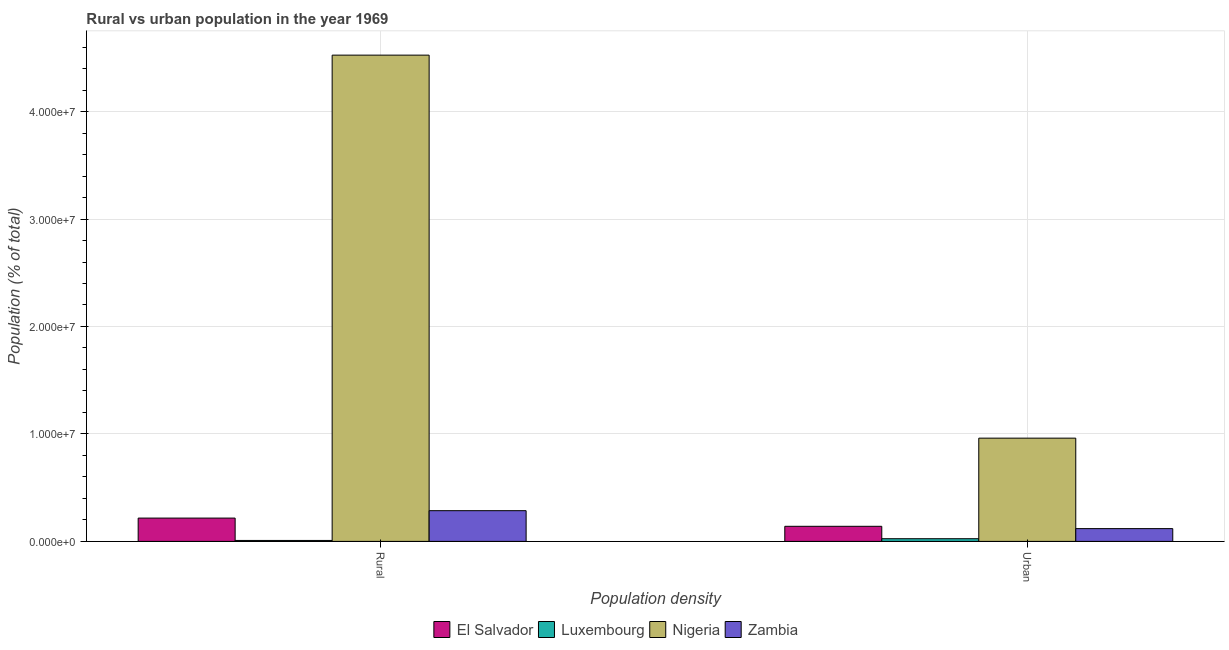How many groups of bars are there?
Your answer should be compact. 2. Are the number of bars on each tick of the X-axis equal?
Offer a very short reply. Yes. How many bars are there on the 2nd tick from the right?
Make the answer very short. 4. What is the label of the 2nd group of bars from the left?
Your answer should be very brief. Urban. What is the urban population density in Luxembourg?
Keep it short and to the point. 2.49e+05. Across all countries, what is the maximum rural population density?
Provide a short and direct response. 4.53e+07. Across all countries, what is the minimum rural population density?
Your response must be concise. 8.81e+04. In which country was the rural population density maximum?
Provide a succinct answer. Nigeria. In which country was the urban population density minimum?
Provide a succinct answer. Luxembourg. What is the total urban population density in the graph?
Make the answer very short. 1.24e+07. What is the difference between the urban population density in Luxembourg and that in Nigeria?
Provide a succinct answer. -9.36e+06. What is the difference between the urban population density in El Salvador and the rural population density in Zambia?
Provide a succinct answer. -1.45e+06. What is the average rural population density per country?
Your answer should be compact. 1.26e+07. What is the difference between the urban population density and rural population density in Zambia?
Your response must be concise. -1.67e+06. What is the ratio of the rural population density in Nigeria to that in El Salvador?
Your response must be concise. 20.87. Is the urban population density in Zambia less than that in Nigeria?
Offer a very short reply. Yes. In how many countries, is the urban population density greater than the average urban population density taken over all countries?
Provide a succinct answer. 1. What does the 2nd bar from the left in Urban represents?
Offer a terse response. Luxembourg. What does the 3rd bar from the right in Urban represents?
Offer a terse response. Luxembourg. How many bars are there?
Give a very brief answer. 8. Are all the bars in the graph horizontal?
Provide a succinct answer. No. Are the values on the major ticks of Y-axis written in scientific E-notation?
Offer a terse response. Yes. Does the graph contain any zero values?
Your response must be concise. No. How are the legend labels stacked?
Your response must be concise. Horizontal. What is the title of the graph?
Your answer should be compact. Rural vs urban population in the year 1969. Does "Guinea" appear as one of the legend labels in the graph?
Give a very brief answer. No. What is the label or title of the X-axis?
Make the answer very short. Population density. What is the label or title of the Y-axis?
Provide a short and direct response. Population (% of total). What is the Population (% of total) of El Salvador in Rural?
Offer a terse response. 2.17e+06. What is the Population (% of total) of Luxembourg in Rural?
Make the answer very short. 8.81e+04. What is the Population (% of total) in Nigeria in Rural?
Offer a terse response. 4.53e+07. What is the Population (% of total) in Zambia in Rural?
Provide a short and direct response. 2.86e+06. What is the Population (% of total) in El Salvador in Urban?
Your response must be concise. 1.40e+06. What is the Population (% of total) of Luxembourg in Urban?
Your answer should be compact. 2.49e+05. What is the Population (% of total) in Nigeria in Urban?
Your response must be concise. 9.61e+06. What is the Population (% of total) of Zambia in Urban?
Offer a terse response. 1.19e+06. Across all Population density, what is the maximum Population (% of total) in El Salvador?
Provide a short and direct response. 2.17e+06. Across all Population density, what is the maximum Population (% of total) of Luxembourg?
Your response must be concise. 2.49e+05. Across all Population density, what is the maximum Population (% of total) in Nigeria?
Make the answer very short. 4.53e+07. Across all Population density, what is the maximum Population (% of total) in Zambia?
Offer a very short reply. 2.86e+06. Across all Population density, what is the minimum Population (% of total) of El Salvador?
Keep it short and to the point. 1.40e+06. Across all Population density, what is the minimum Population (% of total) of Luxembourg?
Your answer should be very brief. 8.81e+04. Across all Population density, what is the minimum Population (% of total) of Nigeria?
Keep it short and to the point. 9.61e+06. Across all Population density, what is the minimum Population (% of total) in Zambia?
Offer a terse response. 1.19e+06. What is the total Population (% of total) in El Salvador in the graph?
Your answer should be very brief. 3.57e+06. What is the total Population (% of total) in Luxembourg in the graph?
Your answer should be compact. 3.38e+05. What is the total Population (% of total) in Nigeria in the graph?
Your answer should be compact. 5.49e+07. What is the total Population (% of total) of Zambia in the graph?
Your response must be concise. 4.05e+06. What is the difference between the Population (% of total) in El Salvador in Rural and that in Urban?
Provide a short and direct response. 7.64e+05. What is the difference between the Population (% of total) of Luxembourg in Rural and that in Urban?
Your answer should be compact. -1.61e+05. What is the difference between the Population (% of total) of Nigeria in Rural and that in Urban?
Your answer should be very brief. 3.56e+07. What is the difference between the Population (% of total) in Zambia in Rural and that in Urban?
Offer a terse response. 1.67e+06. What is the difference between the Population (% of total) of El Salvador in Rural and the Population (% of total) of Luxembourg in Urban?
Offer a terse response. 1.92e+06. What is the difference between the Population (% of total) in El Salvador in Rural and the Population (% of total) in Nigeria in Urban?
Ensure brevity in your answer.  -7.44e+06. What is the difference between the Population (% of total) of El Salvador in Rural and the Population (% of total) of Zambia in Urban?
Offer a terse response. 9.80e+05. What is the difference between the Population (% of total) in Luxembourg in Rural and the Population (% of total) in Nigeria in Urban?
Keep it short and to the point. -9.52e+06. What is the difference between the Population (% of total) in Luxembourg in Rural and the Population (% of total) in Zambia in Urban?
Provide a short and direct response. -1.10e+06. What is the difference between the Population (% of total) of Nigeria in Rural and the Population (% of total) of Zambia in Urban?
Your answer should be compact. 4.41e+07. What is the average Population (% of total) in El Salvador per Population density?
Your response must be concise. 1.79e+06. What is the average Population (% of total) in Luxembourg per Population density?
Keep it short and to the point. 1.69e+05. What is the average Population (% of total) of Nigeria per Population density?
Provide a succinct answer. 2.74e+07. What is the average Population (% of total) of Zambia per Population density?
Ensure brevity in your answer.  2.02e+06. What is the difference between the Population (% of total) in El Salvador and Population (% of total) in Luxembourg in Rural?
Provide a succinct answer. 2.08e+06. What is the difference between the Population (% of total) of El Salvador and Population (% of total) of Nigeria in Rural?
Offer a very short reply. -4.31e+07. What is the difference between the Population (% of total) in El Salvador and Population (% of total) in Zambia in Rural?
Your answer should be compact. -6.90e+05. What is the difference between the Population (% of total) of Luxembourg and Population (% of total) of Nigeria in Rural?
Your answer should be very brief. -4.52e+07. What is the difference between the Population (% of total) of Luxembourg and Population (% of total) of Zambia in Rural?
Offer a very short reply. -2.77e+06. What is the difference between the Population (% of total) in Nigeria and Population (% of total) in Zambia in Rural?
Offer a very short reply. 4.24e+07. What is the difference between the Population (% of total) in El Salvador and Population (% of total) in Luxembourg in Urban?
Your response must be concise. 1.15e+06. What is the difference between the Population (% of total) in El Salvador and Population (% of total) in Nigeria in Urban?
Provide a short and direct response. -8.20e+06. What is the difference between the Population (% of total) of El Salvador and Population (% of total) of Zambia in Urban?
Your answer should be very brief. 2.15e+05. What is the difference between the Population (% of total) of Luxembourg and Population (% of total) of Nigeria in Urban?
Provide a succinct answer. -9.36e+06. What is the difference between the Population (% of total) of Luxembourg and Population (% of total) of Zambia in Urban?
Keep it short and to the point. -9.39e+05. What is the difference between the Population (% of total) of Nigeria and Population (% of total) of Zambia in Urban?
Offer a terse response. 8.42e+06. What is the ratio of the Population (% of total) of El Salvador in Rural to that in Urban?
Your answer should be compact. 1.54. What is the ratio of the Population (% of total) of Luxembourg in Rural to that in Urban?
Make the answer very short. 0.35. What is the ratio of the Population (% of total) of Nigeria in Rural to that in Urban?
Provide a succinct answer. 4.71. What is the ratio of the Population (% of total) of Zambia in Rural to that in Urban?
Keep it short and to the point. 2.4. What is the difference between the highest and the second highest Population (% of total) of El Salvador?
Make the answer very short. 7.64e+05. What is the difference between the highest and the second highest Population (% of total) in Luxembourg?
Your response must be concise. 1.61e+05. What is the difference between the highest and the second highest Population (% of total) in Nigeria?
Your response must be concise. 3.56e+07. What is the difference between the highest and the second highest Population (% of total) of Zambia?
Your answer should be very brief. 1.67e+06. What is the difference between the highest and the lowest Population (% of total) in El Salvador?
Provide a succinct answer. 7.64e+05. What is the difference between the highest and the lowest Population (% of total) in Luxembourg?
Give a very brief answer. 1.61e+05. What is the difference between the highest and the lowest Population (% of total) of Nigeria?
Provide a succinct answer. 3.56e+07. What is the difference between the highest and the lowest Population (% of total) in Zambia?
Offer a very short reply. 1.67e+06. 